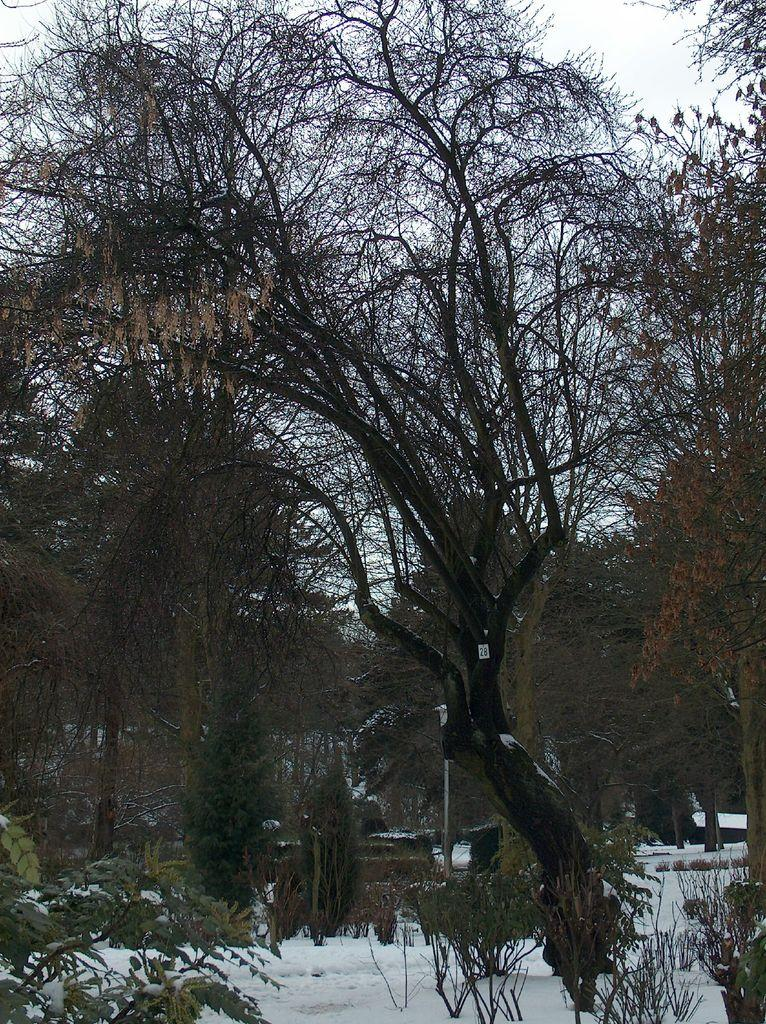What type of vegetation is visible in the image? There are trees in the image. What structure can be seen in the image besides the trees? There is a pole in the image. What might indicate the season or weather in the image? There is snow at the bottom of the image. What color is the eye of the pan in the image? There is no pan or eye present in the image. What type of bait is being used by the trees in the image? There is no bait or fishing activity depicted in the image. 